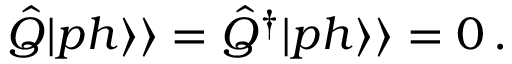Convert formula to latex. <formula><loc_0><loc_0><loc_500><loc_500>\hat { Q } | p h \rangle \rangle = \hat { Q } ^ { \dagger } | p h \rangle \rangle = 0 \, .</formula> 